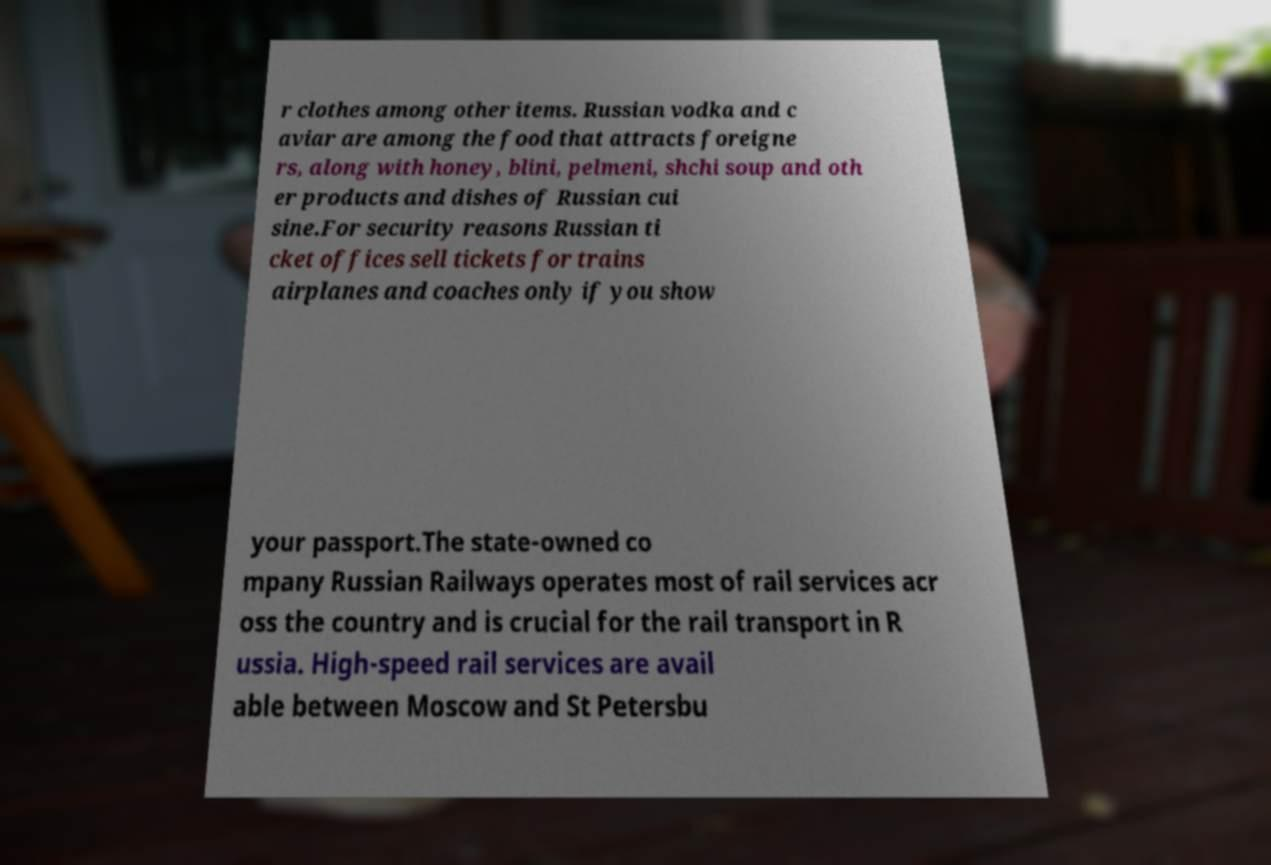Could you assist in decoding the text presented in this image and type it out clearly? r clothes among other items. Russian vodka and c aviar are among the food that attracts foreigne rs, along with honey, blini, pelmeni, shchi soup and oth er products and dishes of Russian cui sine.For security reasons Russian ti cket offices sell tickets for trains airplanes and coaches only if you show your passport.The state-owned co mpany Russian Railways operates most of rail services acr oss the country and is crucial for the rail transport in R ussia. High-speed rail services are avail able between Moscow and St Petersbu 